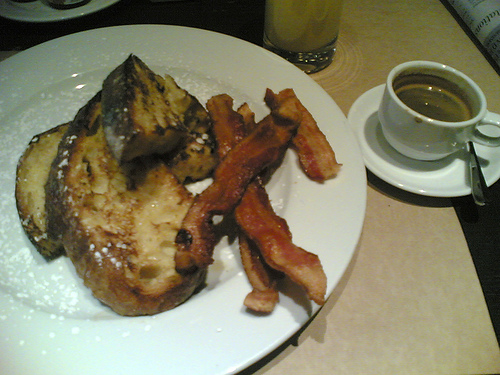<image>
Is the spoon to the right of the bread? No. The spoon is not to the right of the bread. The horizontal positioning shows a different relationship. Is the food on the plate? No. The food is not positioned on the plate. They may be near each other, but the food is not supported by or resting on top of the plate. 